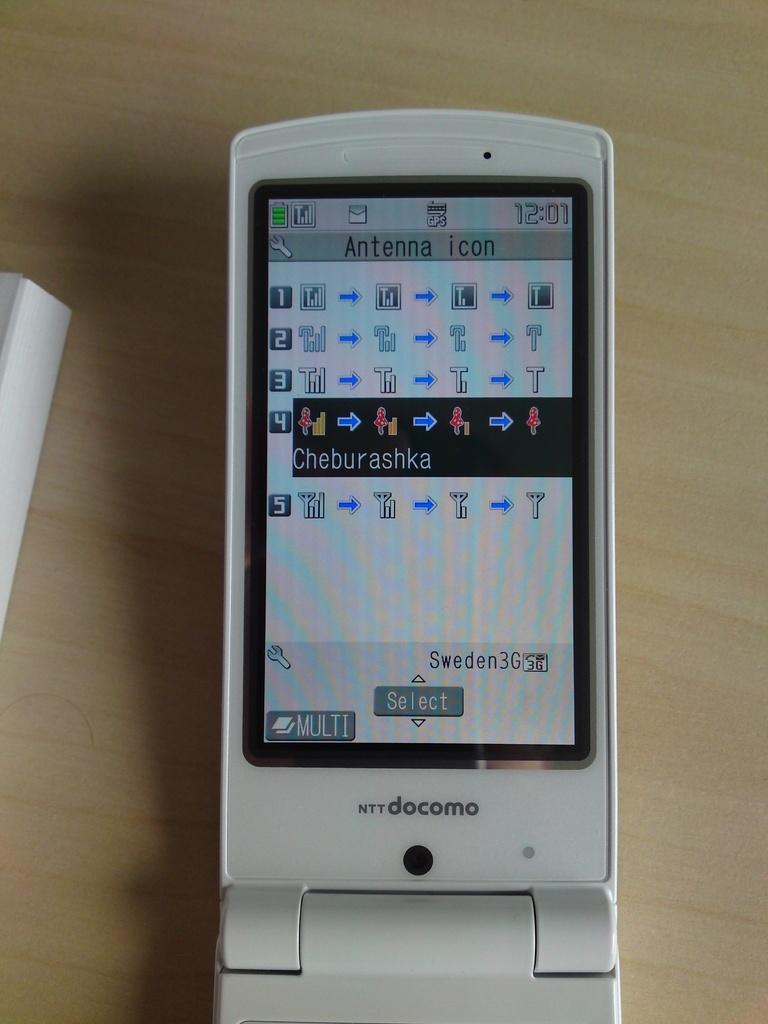<image>
Provide a brief description of the given image. a white docomo branded cell phone shoing its menu screen. 